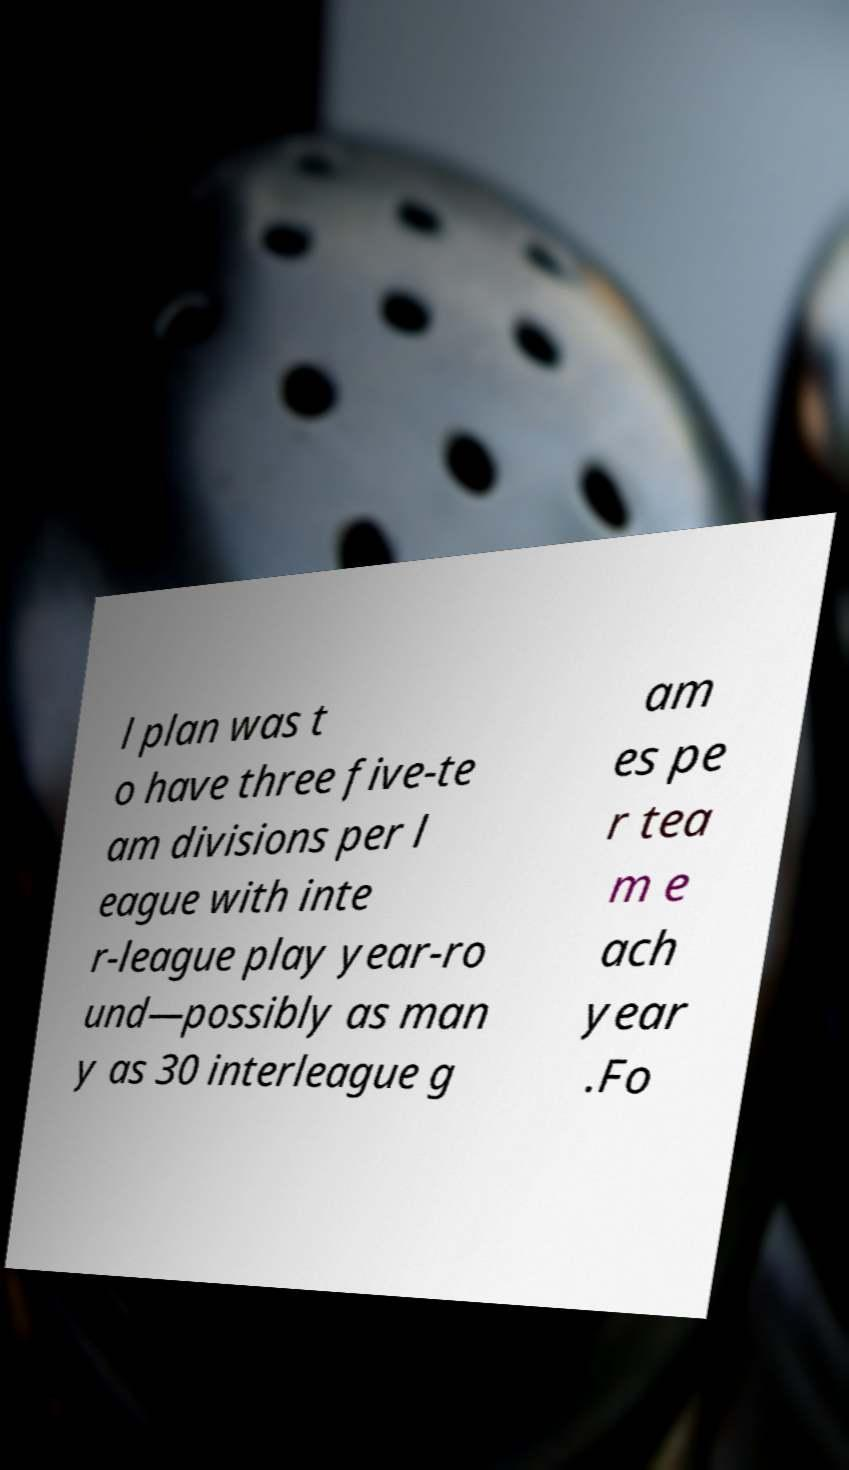Please read and relay the text visible in this image. What does it say? l plan was t o have three five-te am divisions per l eague with inte r-league play year-ro und—possibly as man y as 30 interleague g am es pe r tea m e ach year .Fo 